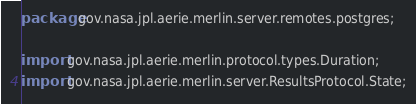Convert code to text. <code><loc_0><loc_0><loc_500><loc_500><_Java_>package gov.nasa.jpl.aerie.merlin.server.remotes.postgres;

import gov.nasa.jpl.aerie.merlin.protocol.types.Duration;
import gov.nasa.jpl.aerie.merlin.server.ResultsProtocol.State;</code> 